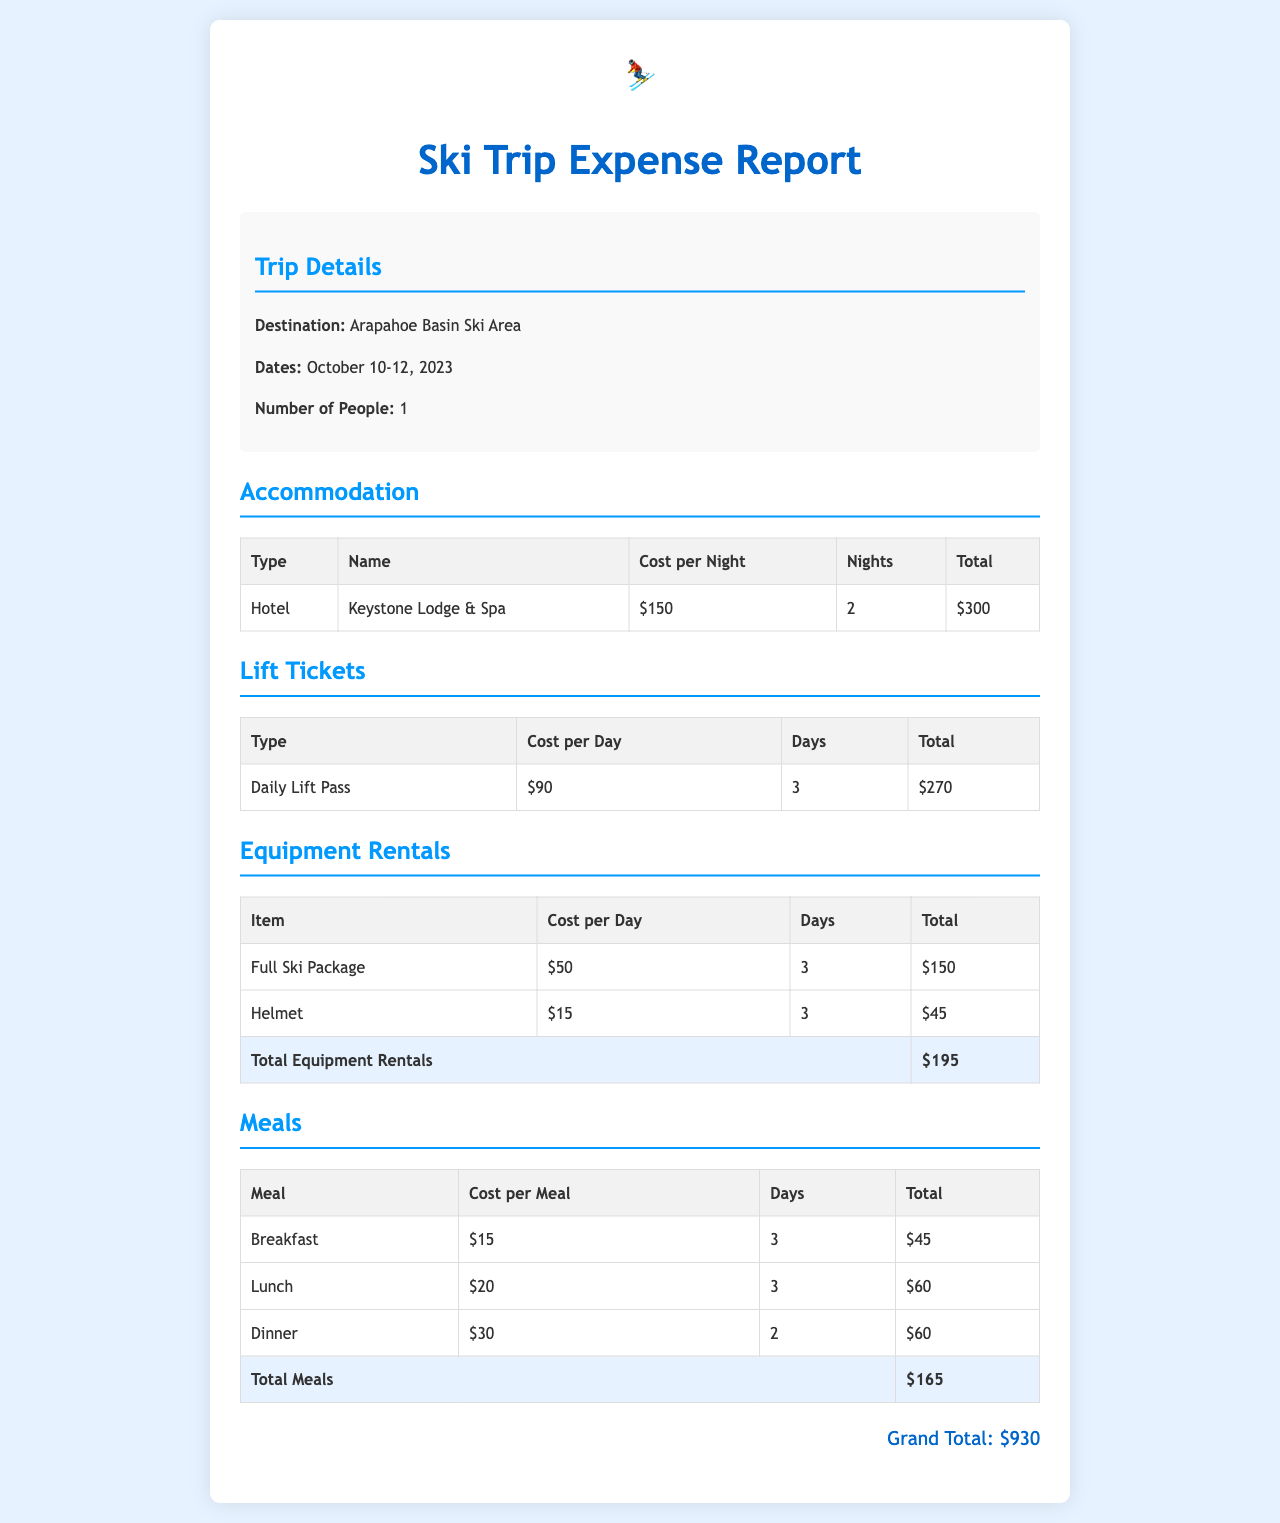What is the destination of the ski trip? The destination mentioned in the document is Arapahoe Basin Ski Area.
Answer: Arapahoe Basin Ski Area What are the dates of the trip? The document states that the trip took place from October 10-12, 2023.
Answer: October 10-12, 2023 How much did the hotel cost per night? The cost per night for accommodation at Keystone Lodge & Spa is listed as $150.
Answer: $150 What is the total cost of lift tickets? The total for lift tickets for 3 days at $90 per day amounts to $270.
Answer: $270 How many days of equipment rentals were included? The document shows equipment rentals were charged for 3 days.
Answer: 3 What was the total cost for meals? The total for meals, including breakfast, lunch, and dinner, is $165.
Answer: $165 How much did the full ski package cost for the entire trip? The cost for the full ski package over 3 days is $150.
Answer: $150 What is the grand total for the ski trip expenses? The grand total expenses for the ski trip is summarized as $930.
Answer: $930 Which meal had the highest cost per meal? The highest cost per meal listed is for dinner at a cost of $30.
Answer: Dinner 